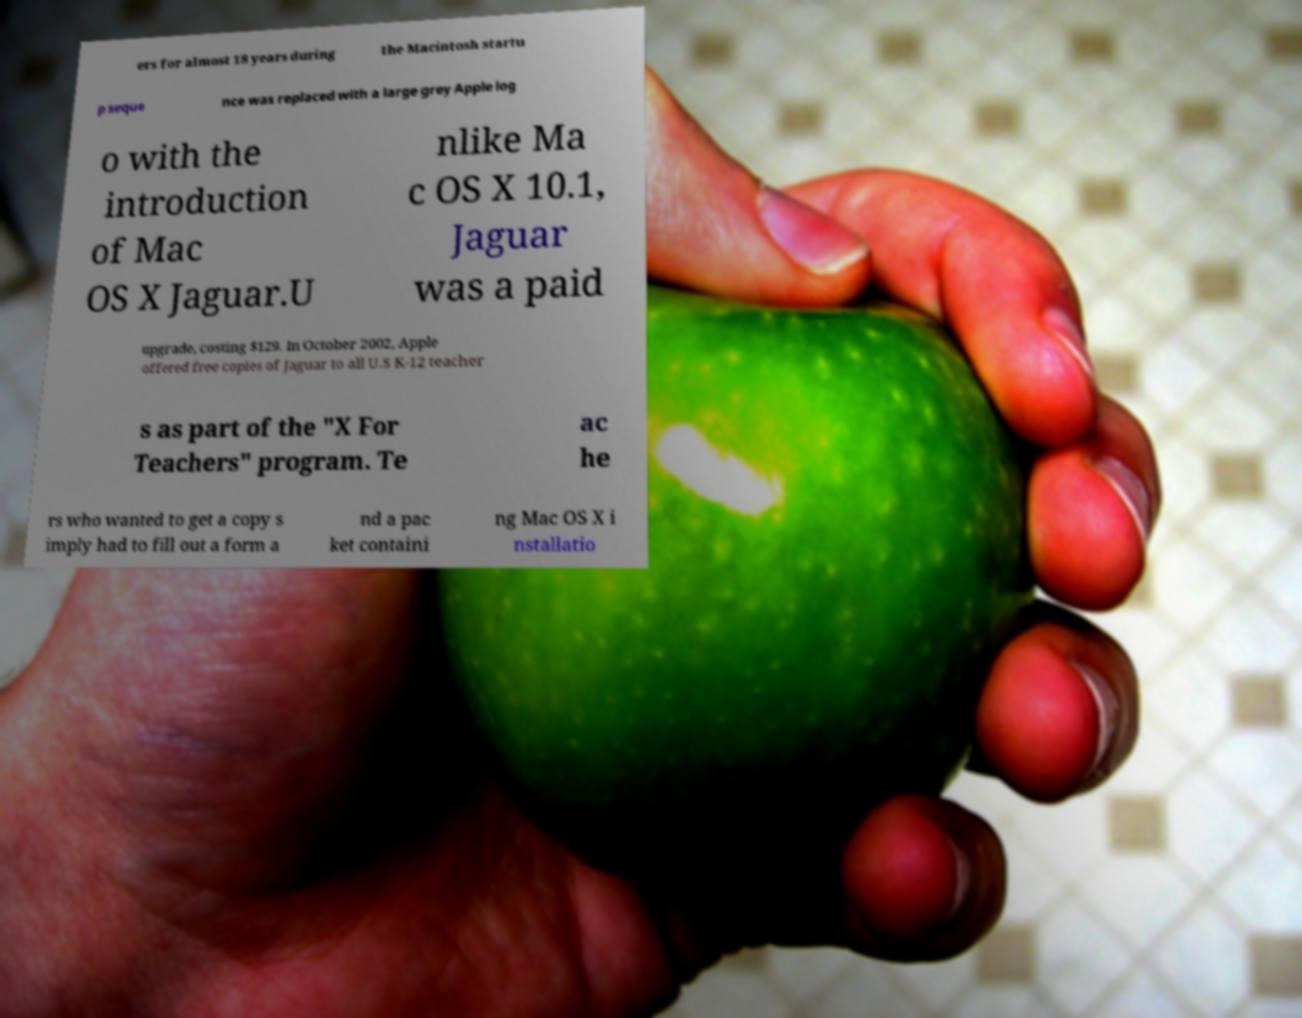There's text embedded in this image that I need extracted. Can you transcribe it verbatim? ers for almost 18 years during the Macintosh startu p seque nce was replaced with a large grey Apple log o with the introduction of Mac OS X Jaguar.U nlike Ma c OS X 10.1, Jaguar was a paid upgrade, costing $129. In October 2002, Apple offered free copies of Jaguar to all U.S K-12 teacher s as part of the "X For Teachers" program. Te ac he rs who wanted to get a copy s imply had to fill out a form a nd a pac ket containi ng Mac OS X i nstallatio 